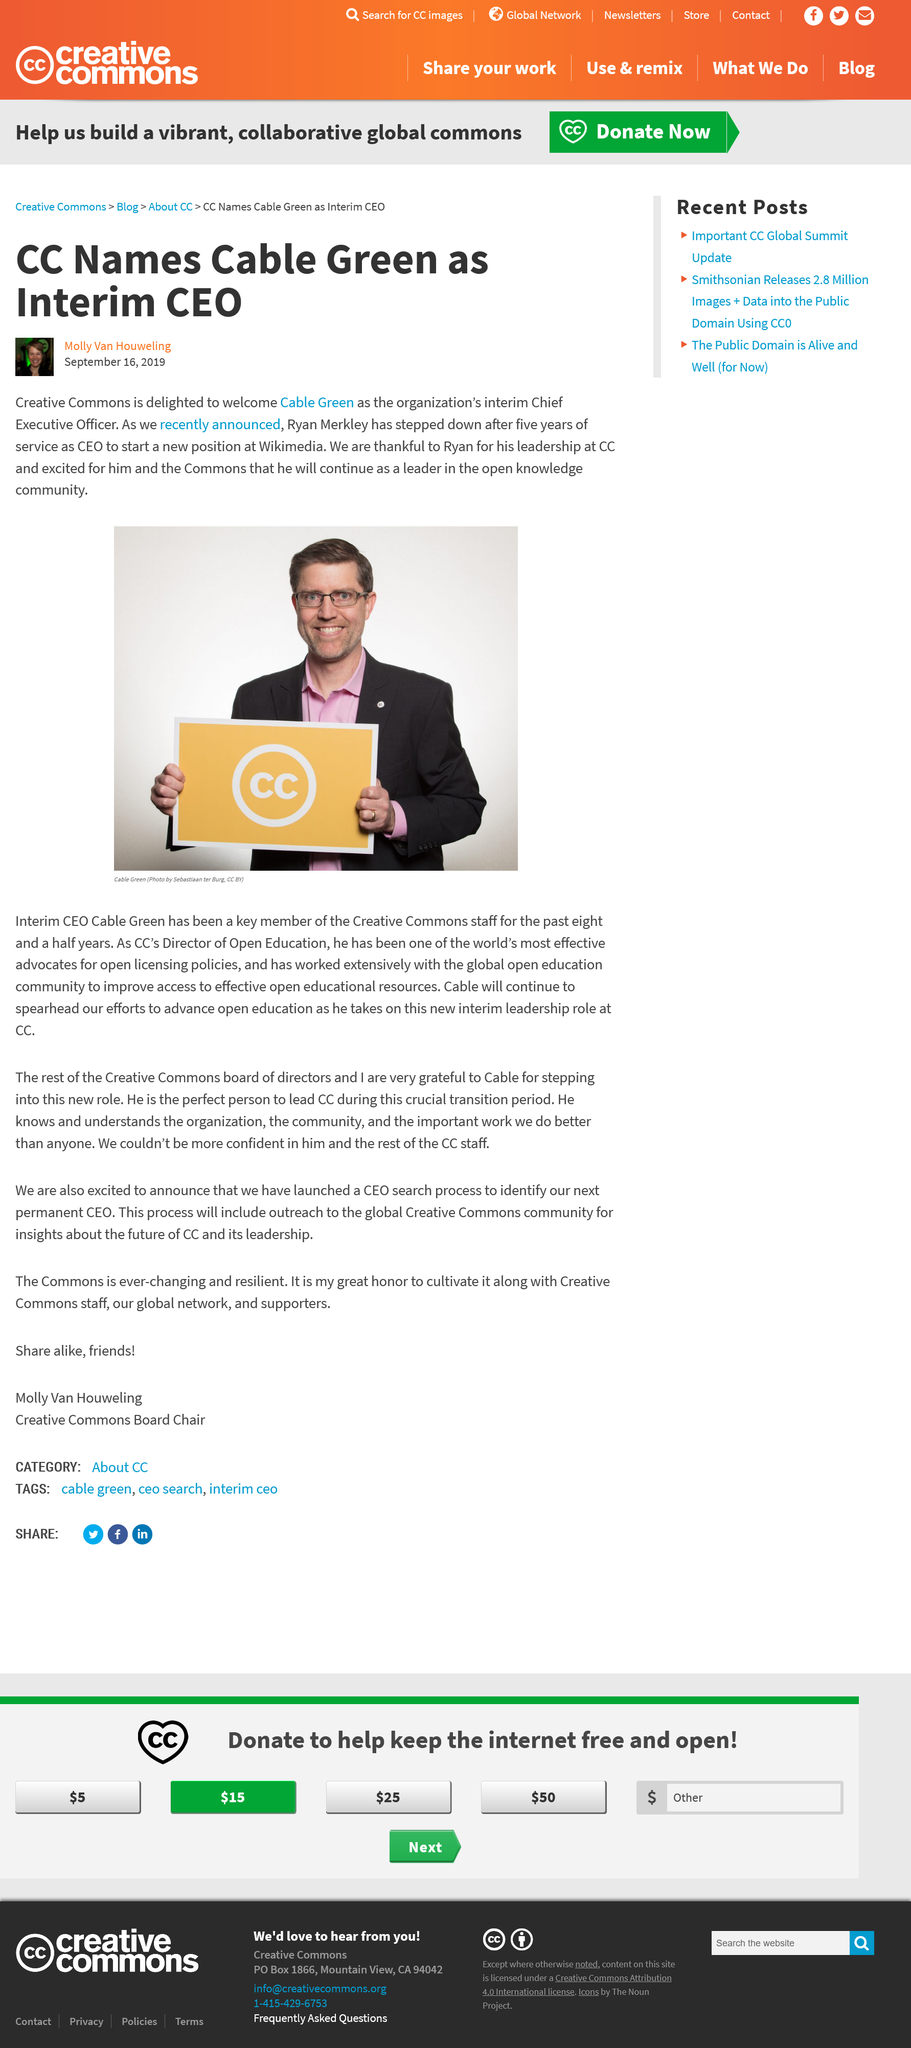Specify some key components in this picture. Ryan Merkley served as the Chief Executive Officer of Creative Commons for a period of five years. Effective immediately, Cable Green has been appointed as the interim Chief Executive Officer of Creative Commons. Cable Green was appointed as the new Chief Executive Officer of Creative Commons, replacing Ryan Merkley. 